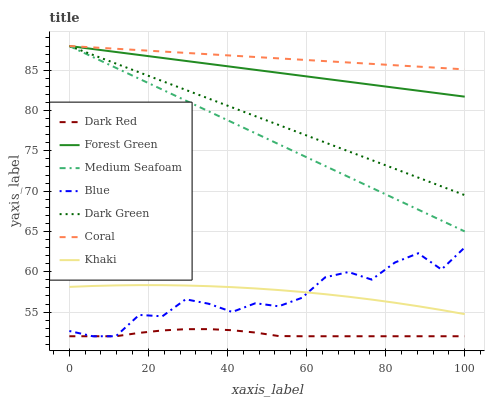Does Dark Red have the minimum area under the curve?
Answer yes or no. Yes. Does Coral have the maximum area under the curve?
Answer yes or no. Yes. Does Khaki have the minimum area under the curve?
Answer yes or no. No. Does Khaki have the maximum area under the curve?
Answer yes or no. No. Is Forest Green the smoothest?
Answer yes or no. Yes. Is Blue the roughest?
Answer yes or no. Yes. Is Khaki the smoothest?
Answer yes or no. No. Is Khaki the roughest?
Answer yes or no. No. Does Blue have the lowest value?
Answer yes or no. Yes. Does Khaki have the lowest value?
Answer yes or no. No. Does Dark Green have the highest value?
Answer yes or no. Yes. Does Khaki have the highest value?
Answer yes or no. No. Is Blue less than Medium Seafoam?
Answer yes or no. Yes. Is Khaki greater than Dark Red?
Answer yes or no. Yes. Does Dark Green intersect Forest Green?
Answer yes or no. Yes. Is Dark Green less than Forest Green?
Answer yes or no. No. Is Dark Green greater than Forest Green?
Answer yes or no. No. Does Blue intersect Medium Seafoam?
Answer yes or no. No. 